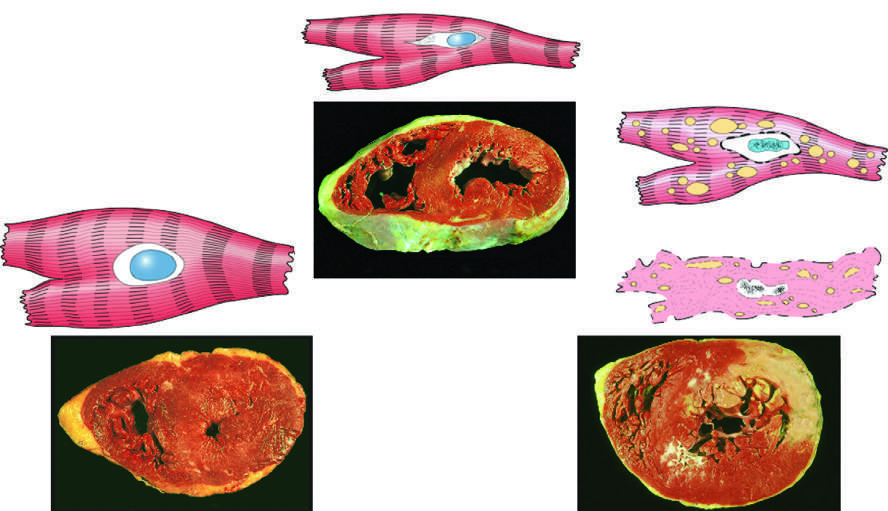s the irreversible injury ischemic coagulative necrosis?
Answer the question using a single word or phrase. Yes 